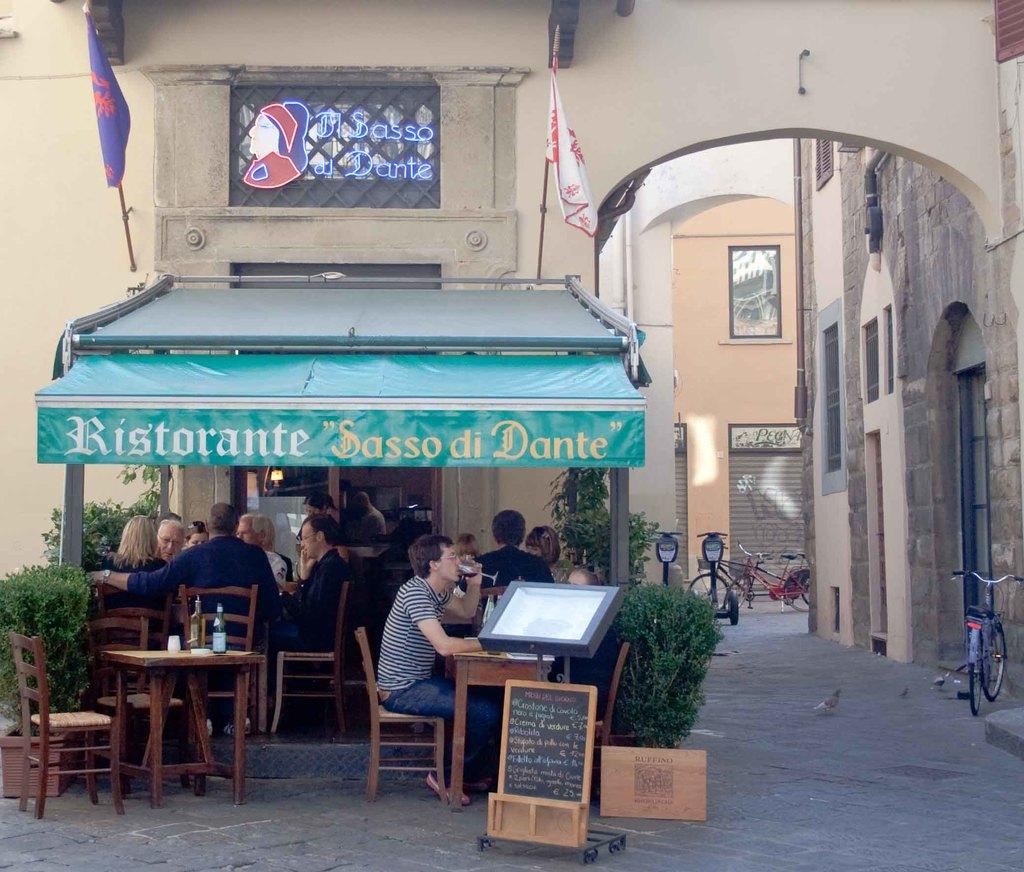What type of structure is visible in the image? There is a building in the image. What mode of transportation can be seen in the image? There is a bicycle in the image. What object is present in the image that might be used for displaying information or advertisements? There is a board in the image. What type of furniture is visible in the image? There are tables and chairs in the image. What items can be seen on the table in the image? There are bottles on the table in the image. What type of dress is the passenger wearing in the image? There is no passenger or dress present in the image. What type of attraction can be seen in the image? There is no attraction present in the image; it features a building, bicycle, board, tables, chairs, and bottles. 